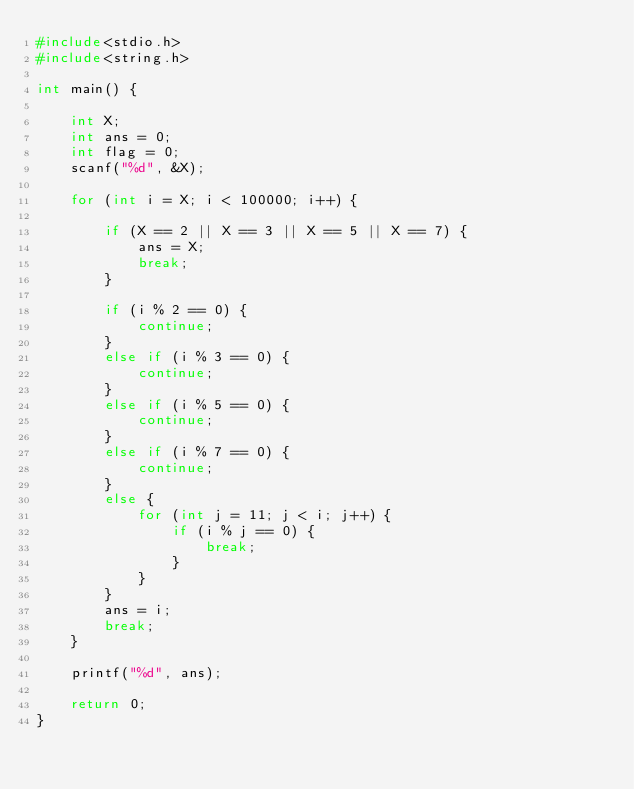<code> <loc_0><loc_0><loc_500><loc_500><_C_>#include<stdio.h>
#include<string.h>

int main() {
	
	int X;
	int ans = 0;
	int flag = 0;
	scanf("%d", &X);

	for (int i = X; i < 100000; i++) {

		if (X == 2 || X == 3 || X == 5 || X == 7) {
			ans = X;
			break;
		}

		if (i % 2 == 0) {
			continue;
		}
		else if (i % 3 == 0) {
			continue;
		}
		else if (i % 5 == 0) {
			continue;
		}
		else if (i % 7 == 0) {
			continue;
		}
		else {
			for (int j = 11; j < i; j++) {
				if (i % j == 0) {
					break;
				}
			}
		}
		ans = i;
		break;
	}

	printf("%d", ans);

	return 0;
}

</code> 